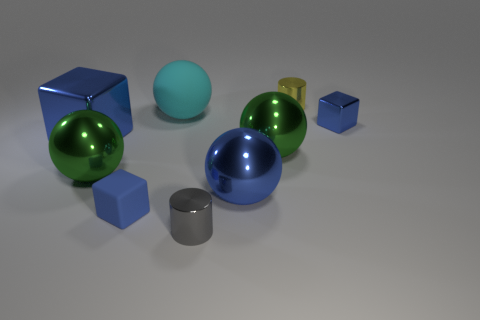How are shadows used in this image? Shadows are used to convey a sense of depth and positional relationship between the objects. Soft shadows suggest a diffused light source and add to the three-dimensional effect, giving clues about the size and shape of the objects. 